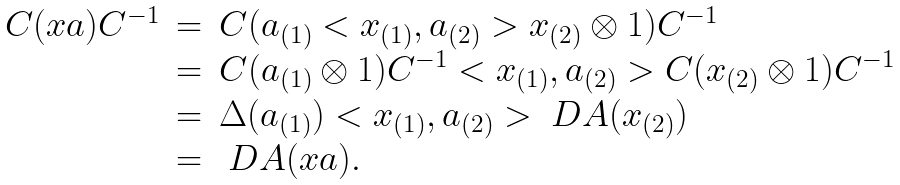Convert formula to latex. <formula><loc_0><loc_0><loc_500><loc_500>\begin{array} { r c l } C ( x a ) C ^ { - 1 } & = & C ( a _ { ( 1 ) } < x _ { ( 1 ) } , a _ { ( 2 ) } > x _ { ( 2 ) } \otimes 1 ) C ^ { - 1 } \\ & = & C ( a _ { ( 1 ) } \otimes 1 ) C ^ { - 1 } < x _ { ( 1 ) } , a _ { ( 2 ) } > C ( x _ { ( 2 ) } \otimes 1 ) C ^ { - 1 } \\ & = & \Delta ( a _ { ( 1 ) } ) < x _ { ( 1 ) } , a _ { ( 2 ) } > \ D A ( x _ { ( 2 ) } ) \\ & = & \ D A ( x a ) . \end{array}</formula> 